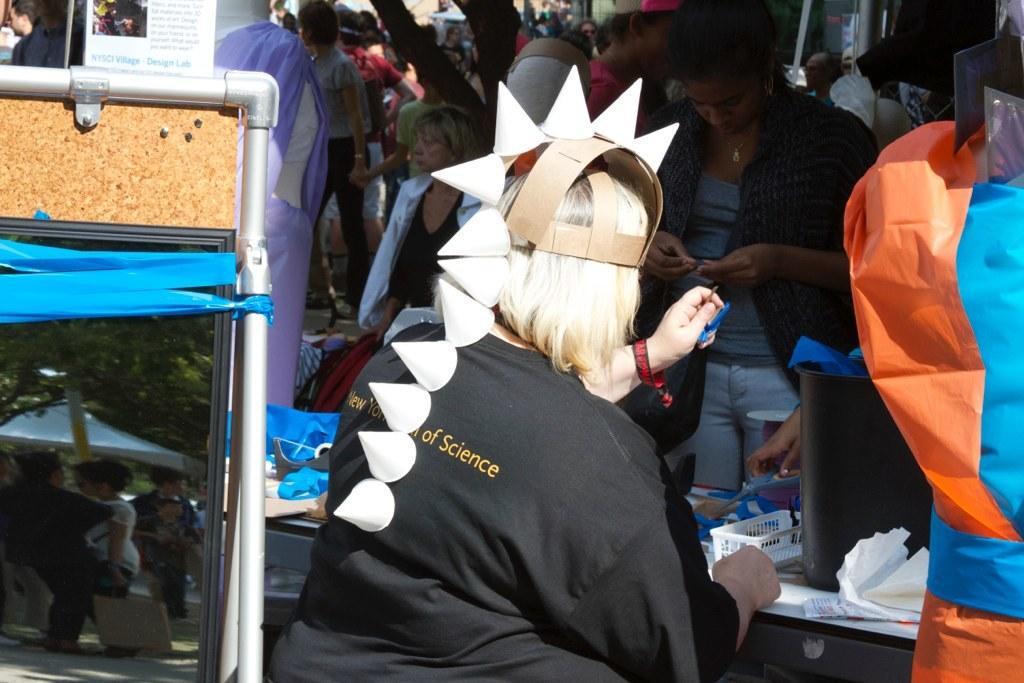Describe this image in one or two sentences. In this picture we can see the woman sitting in a front wearing black t-shirt. Behind we can see some people are standing. On the right corner there is a pipe frame and glass mirror. 